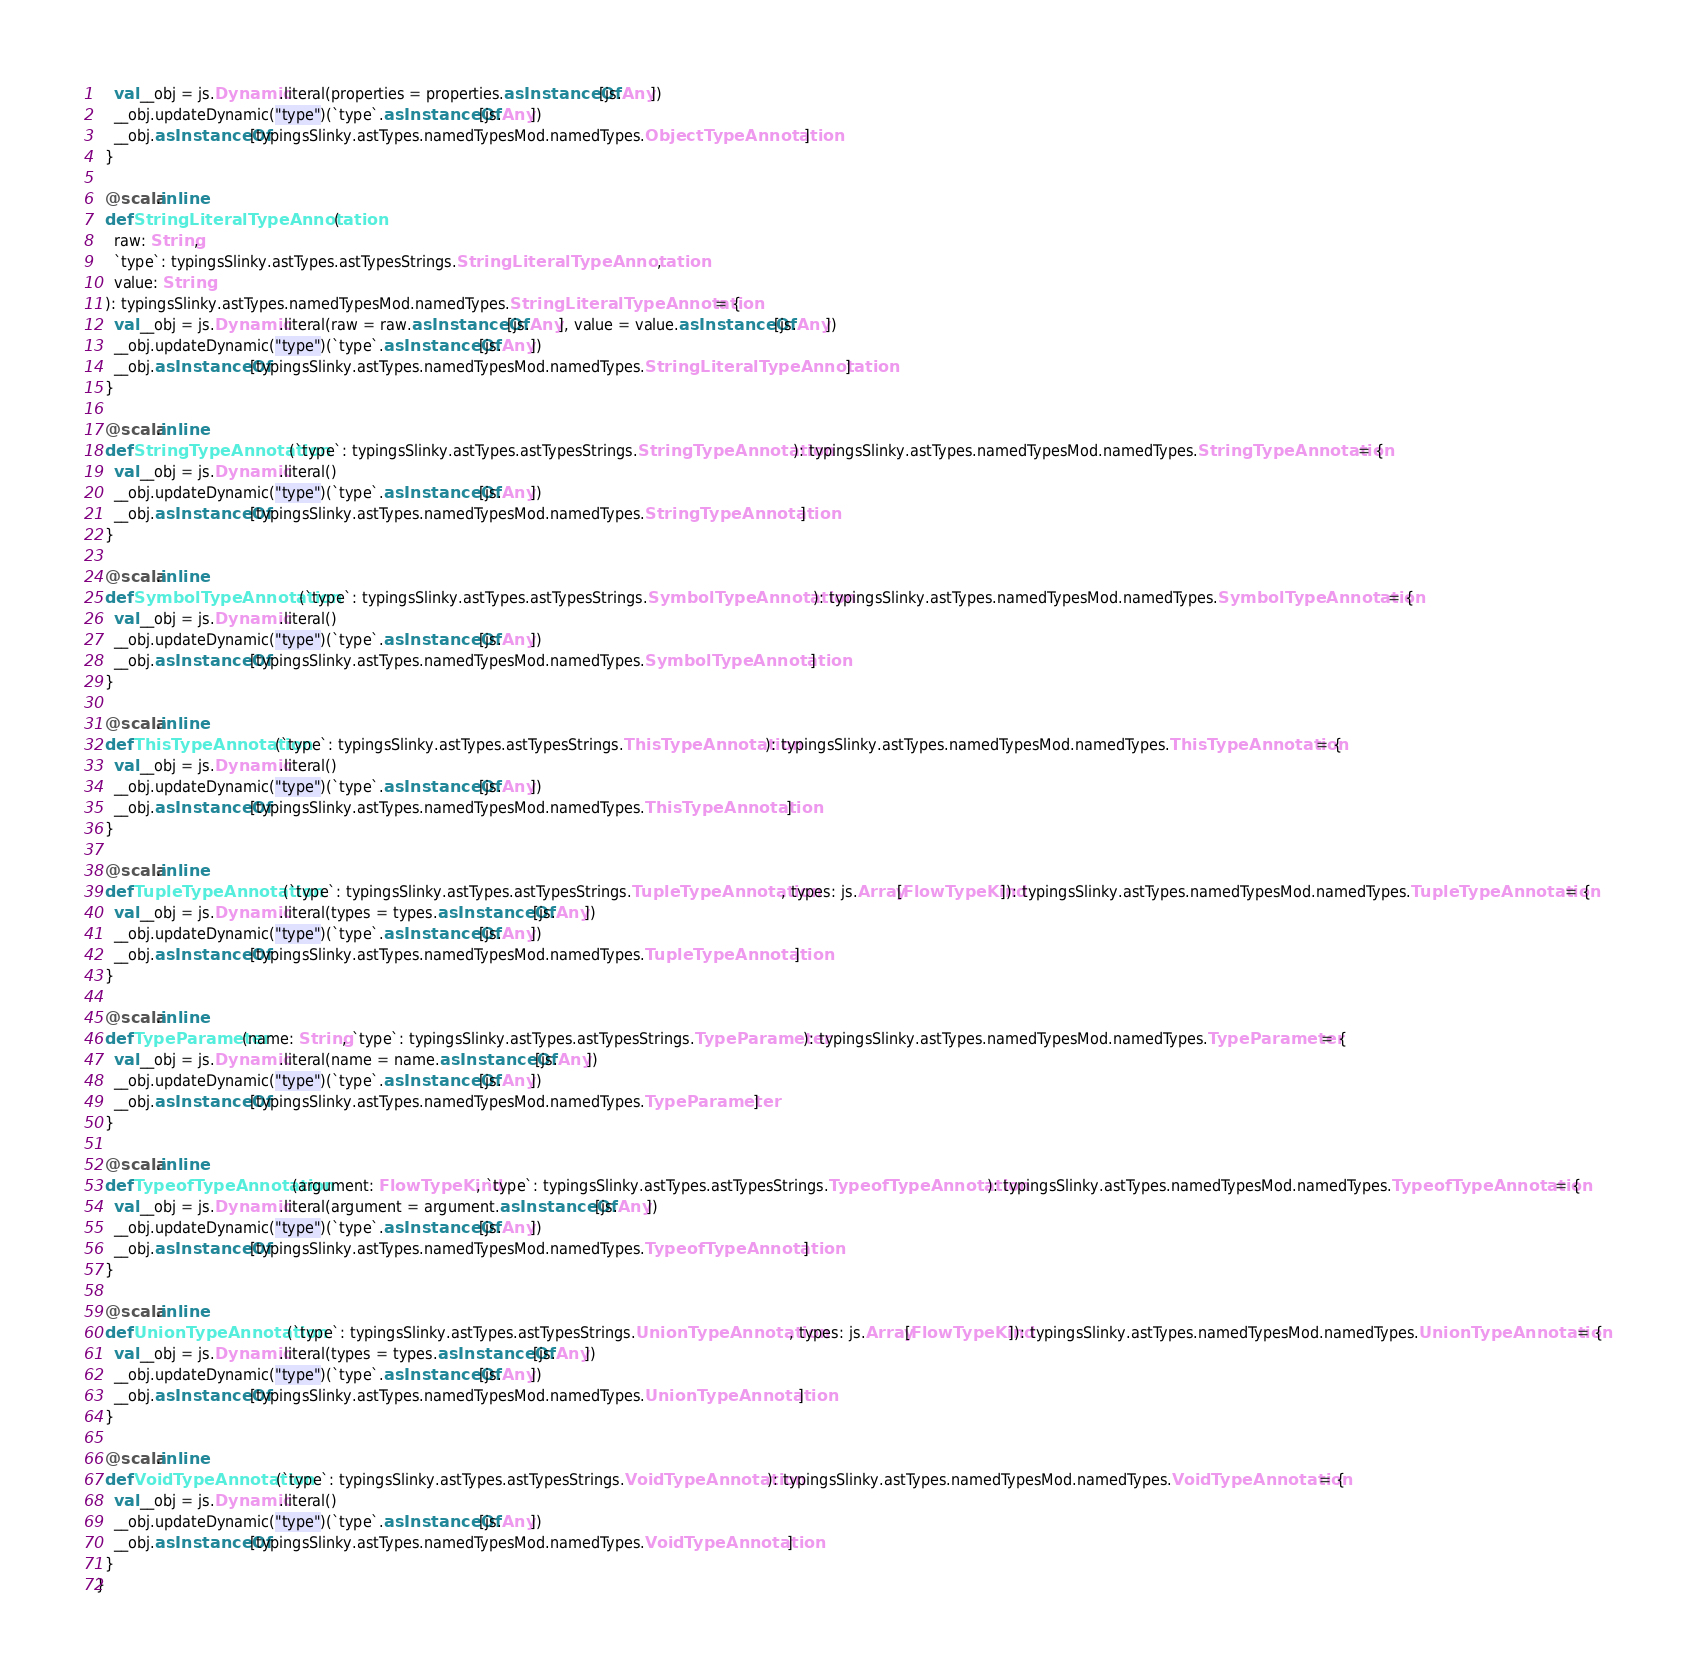Convert code to text. <code><loc_0><loc_0><loc_500><loc_500><_Scala_>    val __obj = js.Dynamic.literal(properties = properties.asInstanceOf[js.Any])
    __obj.updateDynamic("type")(`type`.asInstanceOf[js.Any])
    __obj.asInstanceOf[typingsSlinky.astTypes.namedTypesMod.namedTypes.ObjectTypeAnnotation]
  }
  
  @scala.inline
  def StringLiteralTypeAnnotation(
    raw: String,
    `type`: typingsSlinky.astTypes.astTypesStrings.StringLiteralTypeAnnotation,
    value: String
  ): typingsSlinky.astTypes.namedTypesMod.namedTypes.StringLiteralTypeAnnotation = {
    val __obj = js.Dynamic.literal(raw = raw.asInstanceOf[js.Any], value = value.asInstanceOf[js.Any])
    __obj.updateDynamic("type")(`type`.asInstanceOf[js.Any])
    __obj.asInstanceOf[typingsSlinky.astTypes.namedTypesMod.namedTypes.StringLiteralTypeAnnotation]
  }
  
  @scala.inline
  def StringTypeAnnotation(`type`: typingsSlinky.astTypes.astTypesStrings.StringTypeAnnotation): typingsSlinky.astTypes.namedTypesMod.namedTypes.StringTypeAnnotation = {
    val __obj = js.Dynamic.literal()
    __obj.updateDynamic("type")(`type`.asInstanceOf[js.Any])
    __obj.asInstanceOf[typingsSlinky.astTypes.namedTypesMod.namedTypes.StringTypeAnnotation]
  }
  
  @scala.inline
  def SymbolTypeAnnotation(`type`: typingsSlinky.astTypes.astTypesStrings.SymbolTypeAnnotation): typingsSlinky.astTypes.namedTypesMod.namedTypes.SymbolTypeAnnotation = {
    val __obj = js.Dynamic.literal()
    __obj.updateDynamic("type")(`type`.asInstanceOf[js.Any])
    __obj.asInstanceOf[typingsSlinky.astTypes.namedTypesMod.namedTypes.SymbolTypeAnnotation]
  }
  
  @scala.inline
  def ThisTypeAnnotation(`type`: typingsSlinky.astTypes.astTypesStrings.ThisTypeAnnotation): typingsSlinky.astTypes.namedTypesMod.namedTypes.ThisTypeAnnotation = {
    val __obj = js.Dynamic.literal()
    __obj.updateDynamic("type")(`type`.asInstanceOf[js.Any])
    __obj.asInstanceOf[typingsSlinky.astTypes.namedTypesMod.namedTypes.ThisTypeAnnotation]
  }
  
  @scala.inline
  def TupleTypeAnnotation(`type`: typingsSlinky.astTypes.astTypesStrings.TupleTypeAnnotation, types: js.Array[FlowTypeKind]): typingsSlinky.astTypes.namedTypesMod.namedTypes.TupleTypeAnnotation = {
    val __obj = js.Dynamic.literal(types = types.asInstanceOf[js.Any])
    __obj.updateDynamic("type")(`type`.asInstanceOf[js.Any])
    __obj.asInstanceOf[typingsSlinky.astTypes.namedTypesMod.namedTypes.TupleTypeAnnotation]
  }
  
  @scala.inline
  def TypeParameter(name: String, `type`: typingsSlinky.astTypes.astTypesStrings.TypeParameter): typingsSlinky.astTypes.namedTypesMod.namedTypes.TypeParameter = {
    val __obj = js.Dynamic.literal(name = name.asInstanceOf[js.Any])
    __obj.updateDynamic("type")(`type`.asInstanceOf[js.Any])
    __obj.asInstanceOf[typingsSlinky.astTypes.namedTypesMod.namedTypes.TypeParameter]
  }
  
  @scala.inline
  def TypeofTypeAnnotation(argument: FlowTypeKind, `type`: typingsSlinky.astTypes.astTypesStrings.TypeofTypeAnnotation): typingsSlinky.astTypes.namedTypesMod.namedTypes.TypeofTypeAnnotation = {
    val __obj = js.Dynamic.literal(argument = argument.asInstanceOf[js.Any])
    __obj.updateDynamic("type")(`type`.asInstanceOf[js.Any])
    __obj.asInstanceOf[typingsSlinky.astTypes.namedTypesMod.namedTypes.TypeofTypeAnnotation]
  }
  
  @scala.inline
  def UnionTypeAnnotation(`type`: typingsSlinky.astTypes.astTypesStrings.UnionTypeAnnotation, types: js.Array[FlowTypeKind]): typingsSlinky.astTypes.namedTypesMod.namedTypes.UnionTypeAnnotation = {
    val __obj = js.Dynamic.literal(types = types.asInstanceOf[js.Any])
    __obj.updateDynamic("type")(`type`.asInstanceOf[js.Any])
    __obj.asInstanceOf[typingsSlinky.astTypes.namedTypesMod.namedTypes.UnionTypeAnnotation]
  }
  
  @scala.inline
  def VoidTypeAnnotation(`type`: typingsSlinky.astTypes.astTypesStrings.VoidTypeAnnotation): typingsSlinky.astTypes.namedTypesMod.namedTypes.VoidTypeAnnotation = {
    val __obj = js.Dynamic.literal()
    __obj.updateDynamic("type")(`type`.asInstanceOf[js.Any])
    __obj.asInstanceOf[typingsSlinky.astTypes.namedTypesMod.namedTypes.VoidTypeAnnotation]
  }
}
</code> 